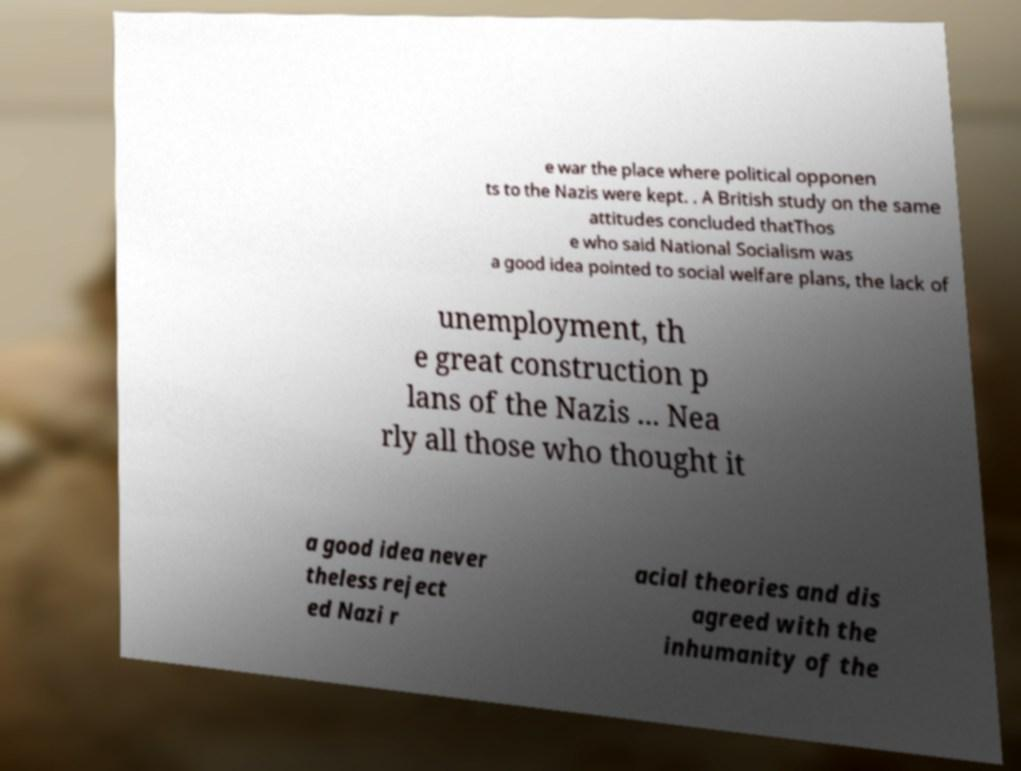What messages or text are displayed in this image? I need them in a readable, typed format. e war the place where political opponen ts to the Nazis were kept. . A British study on the same attitudes concluded thatThos e who said National Socialism was a good idea pointed to social welfare plans, the lack of unemployment, th e great construction p lans of the Nazis ... Nea rly all those who thought it a good idea never theless reject ed Nazi r acial theories and dis agreed with the inhumanity of the 